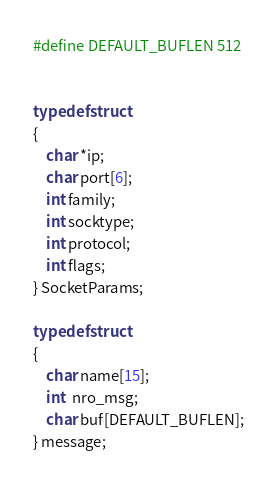Convert code to text. <code><loc_0><loc_0><loc_500><loc_500><_C_>#define DEFAULT_BUFLEN 512


typedef struct
{
	char *ip;
	char port[6];
	int family;
	int socktype;
	int protocol;
	int flags;
} SocketParams;

typedef struct
{
	char name[15];
	int  nro_msg;
	char buf[DEFAULT_BUFLEN];
} message;
</code> 